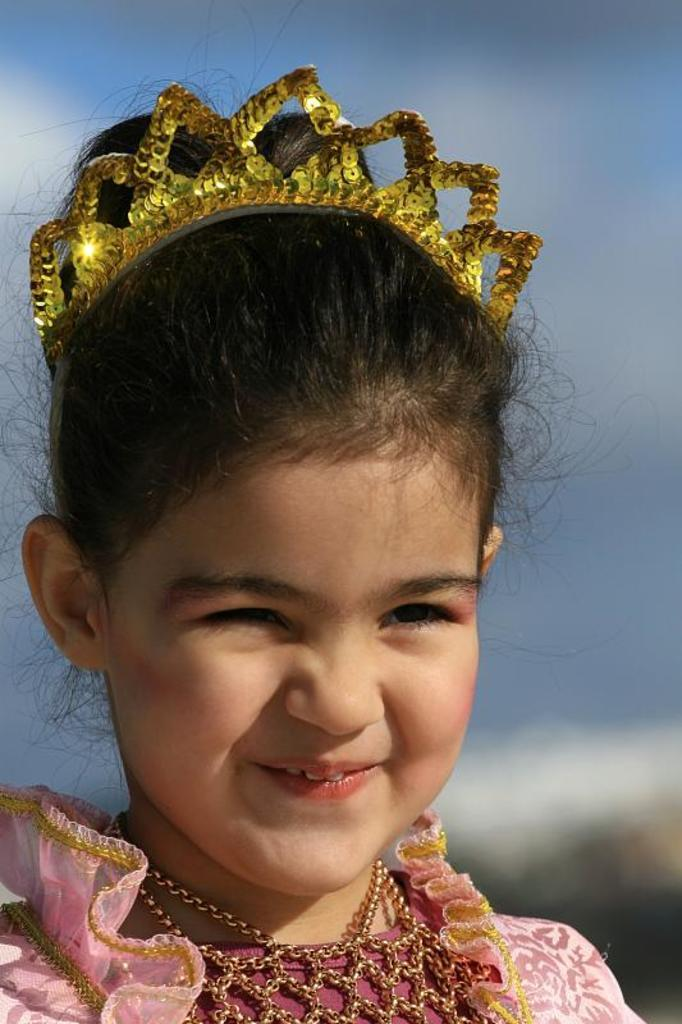Who is the main subject in the image? There is a girl in the image. What is the girl wearing? The girl is wearing a pink dress and a golden crown. What is the girl's facial expression? The girl is smiling. What can be seen in the background of the image? There are clouds in the background of the image, and the sky is blue. How does the girl increase the size of the snowflakes in the image? There is no snow or snowflakes present in the image, so the girl cannot increase their size. 